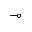<formula> <loc_0><loc_0><loc_500><loc_500>\mu l t i m a p</formula> 